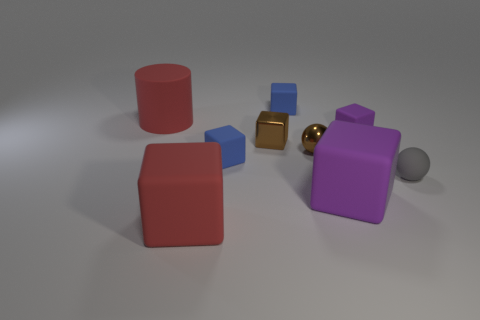What number of rubber things are either red objects or big purple cubes?
Keep it short and to the point. 3. Is there anything else that is the same material as the small purple object?
Your answer should be very brief. Yes. Is there a purple cube in front of the ball that is left of the tiny purple rubber thing?
Your answer should be very brief. Yes. How many things are purple rubber blocks that are in front of the metal sphere or small metal objects in front of the small metallic block?
Your answer should be very brief. 2. Is there anything else that is the same color as the small shiny cube?
Make the answer very short. Yes. The small metal thing left of the tiny ball that is on the left side of the large object that is on the right side of the tiny brown shiny cube is what color?
Your answer should be very brief. Brown. There is a purple cube that is in front of the tiny blue object in front of the red matte cylinder; how big is it?
Give a very brief answer. Large. There is a block that is on the left side of the shiny ball and in front of the gray thing; what material is it?
Your response must be concise. Rubber. There is a cylinder; is its size the same as the purple matte thing that is behind the rubber sphere?
Keep it short and to the point. No. Are there any large purple cubes?
Your answer should be compact. Yes. 